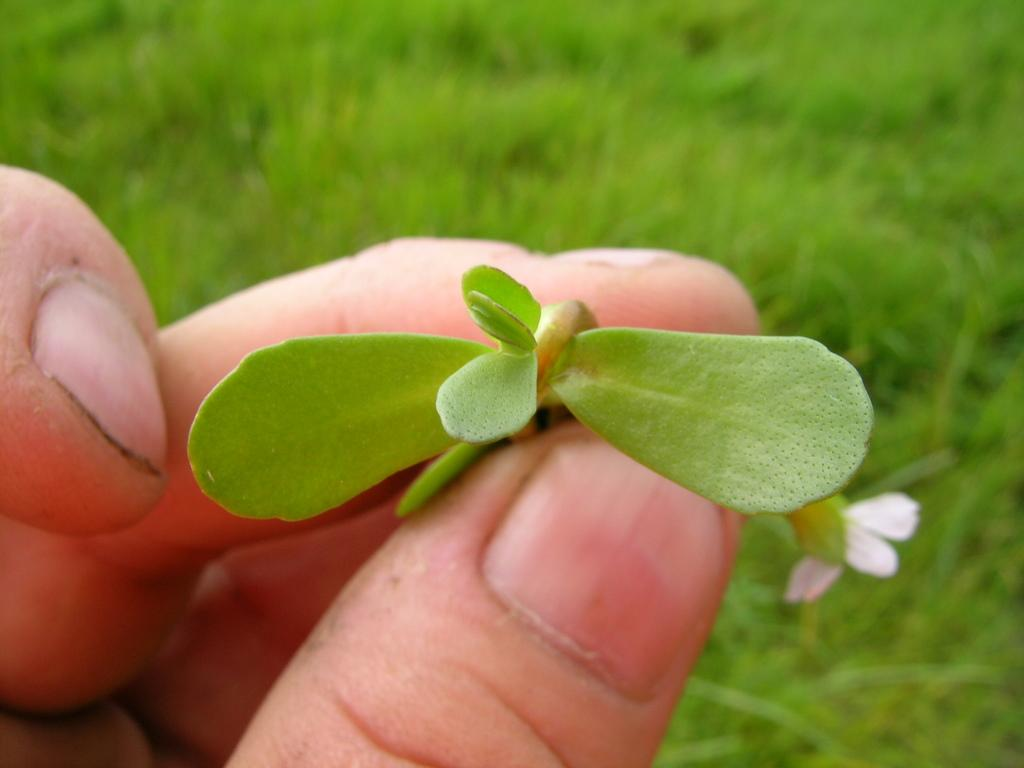Where was the picture taken? The picture was clicked outside. What can be seen in the left corner of the image? A person's fingers holding green leaves are visible in the left corner of the image. What type of vegetation is present in the background of the image? There is green grass and plants in the background of the image. How many roses can be seen in the image? There are no roses present in the image. Is there a cellar visible in the image? There is no cellar present in the image; it was taken outside. 